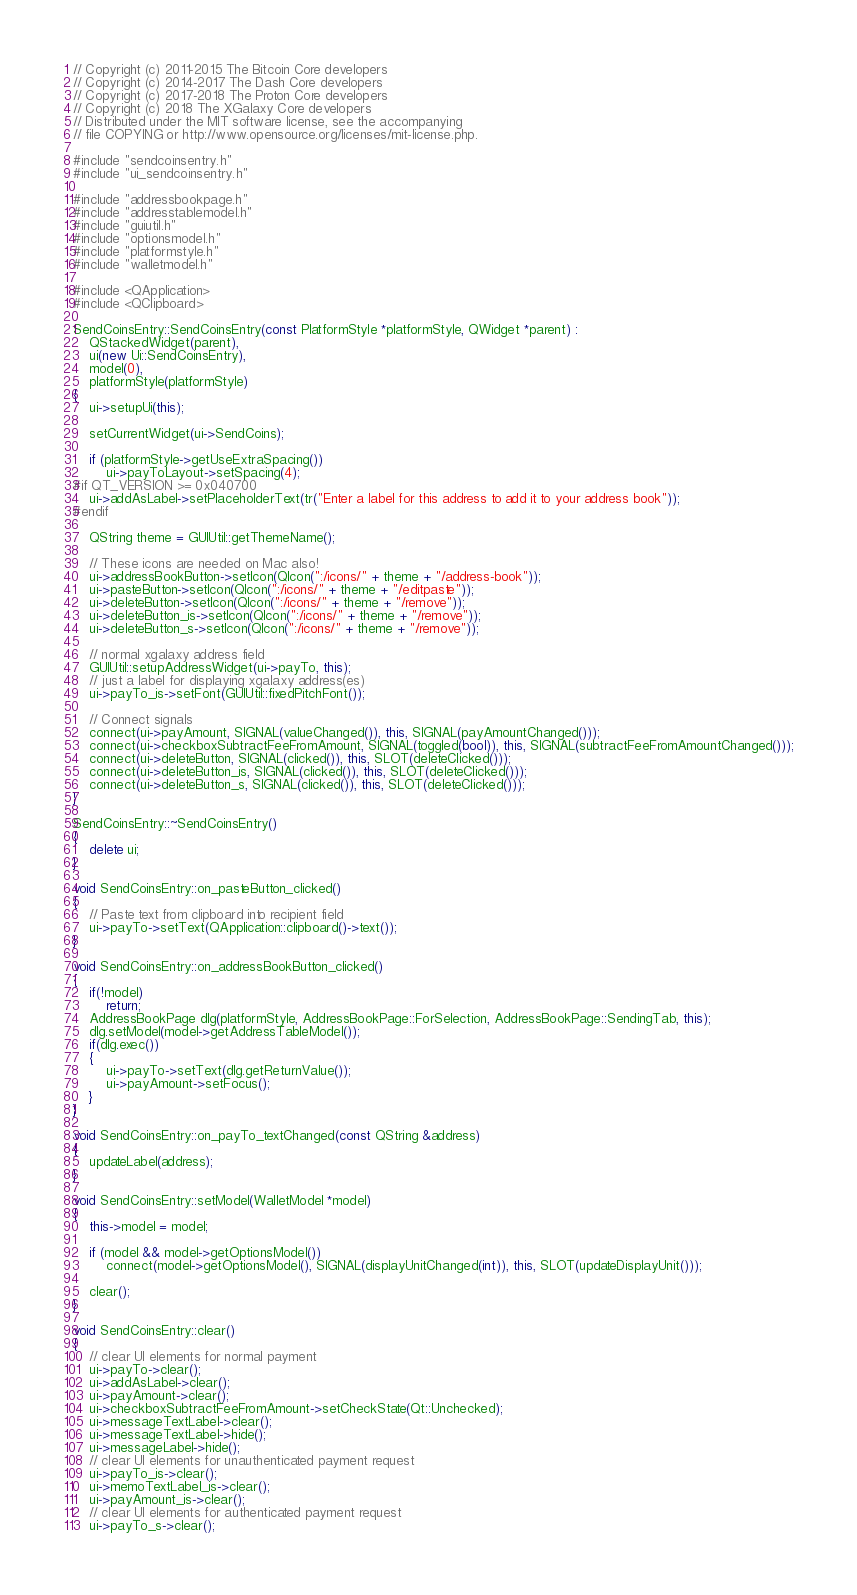Convert code to text. <code><loc_0><loc_0><loc_500><loc_500><_C++_>// Copyright (c) 2011-2015 The Bitcoin Core developers
// Copyright (c) 2014-2017 The Dash Core developers
// Copyright (c) 2017-2018 The Proton Core developers
// Copyright (c) 2018 The XGalaxy Core developers
// Distributed under the MIT software license, see the accompanying
// file COPYING or http://www.opensource.org/licenses/mit-license.php.

#include "sendcoinsentry.h"
#include "ui_sendcoinsentry.h"

#include "addressbookpage.h"
#include "addresstablemodel.h"
#include "guiutil.h"
#include "optionsmodel.h"
#include "platformstyle.h"
#include "walletmodel.h"

#include <QApplication>
#include <QClipboard>

SendCoinsEntry::SendCoinsEntry(const PlatformStyle *platformStyle, QWidget *parent) :
    QStackedWidget(parent),
    ui(new Ui::SendCoinsEntry),
    model(0),
    platformStyle(platformStyle)
{
    ui->setupUi(this);

    setCurrentWidget(ui->SendCoins);

    if (platformStyle->getUseExtraSpacing())
        ui->payToLayout->setSpacing(4);
#if QT_VERSION >= 0x040700
    ui->addAsLabel->setPlaceholderText(tr("Enter a label for this address to add it to your address book"));
#endif

    QString theme = GUIUtil::getThemeName();

    // These icons are needed on Mac also!
    ui->addressBookButton->setIcon(QIcon(":/icons/" + theme + "/address-book"));
    ui->pasteButton->setIcon(QIcon(":/icons/" + theme + "/editpaste"));
    ui->deleteButton->setIcon(QIcon(":/icons/" + theme + "/remove"));
    ui->deleteButton_is->setIcon(QIcon(":/icons/" + theme + "/remove"));
    ui->deleteButton_s->setIcon(QIcon(":/icons/" + theme + "/remove"));
      
    // normal xgalaxy address field
    GUIUtil::setupAddressWidget(ui->payTo, this);
    // just a label for displaying xgalaxy address(es)
    ui->payTo_is->setFont(GUIUtil::fixedPitchFont());

    // Connect signals
    connect(ui->payAmount, SIGNAL(valueChanged()), this, SIGNAL(payAmountChanged()));
    connect(ui->checkboxSubtractFeeFromAmount, SIGNAL(toggled(bool)), this, SIGNAL(subtractFeeFromAmountChanged()));
    connect(ui->deleteButton, SIGNAL(clicked()), this, SLOT(deleteClicked()));
    connect(ui->deleteButton_is, SIGNAL(clicked()), this, SLOT(deleteClicked()));
    connect(ui->deleteButton_s, SIGNAL(clicked()), this, SLOT(deleteClicked()));
}

SendCoinsEntry::~SendCoinsEntry()
{
    delete ui;
}

void SendCoinsEntry::on_pasteButton_clicked()
{
    // Paste text from clipboard into recipient field
    ui->payTo->setText(QApplication::clipboard()->text());
}

void SendCoinsEntry::on_addressBookButton_clicked()
{
    if(!model)
        return;
    AddressBookPage dlg(platformStyle, AddressBookPage::ForSelection, AddressBookPage::SendingTab, this);
    dlg.setModel(model->getAddressTableModel());
    if(dlg.exec())
    {
        ui->payTo->setText(dlg.getReturnValue());
        ui->payAmount->setFocus();
    }
}

void SendCoinsEntry::on_payTo_textChanged(const QString &address)
{
    updateLabel(address);
}

void SendCoinsEntry::setModel(WalletModel *model)
{
    this->model = model;

    if (model && model->getOptionsModel())
        connect(model->getOptionsModel(), SIGNAL(displayUnitChanged(int)), this, SLOT(updateDisplayUnit()));

    clear();
}

void SendCoinsEntry::clear()
{
    // clear UI elements for normal payment
    ui->payTo->clear();
    ui->addAsLabel->clear();
    ui->payAmount->clear();
    ui->checkboxSubtractFeeFromAmount->setCheckState(Qt::Unchecked);
    ui->messageTextLabel->clear();
    ui->messageTextLabel->hide();
    ui->messageLabel->hide();
    // clear UI elements for unauthenticated payment request
    ui->payTo_is->clear();
    ui->memoTextLabel_is->clear();
    ui->payAmount_is->clear();
    // clear UI elements for authenticated payment request
    ui->payTo_s->clear();</code> 